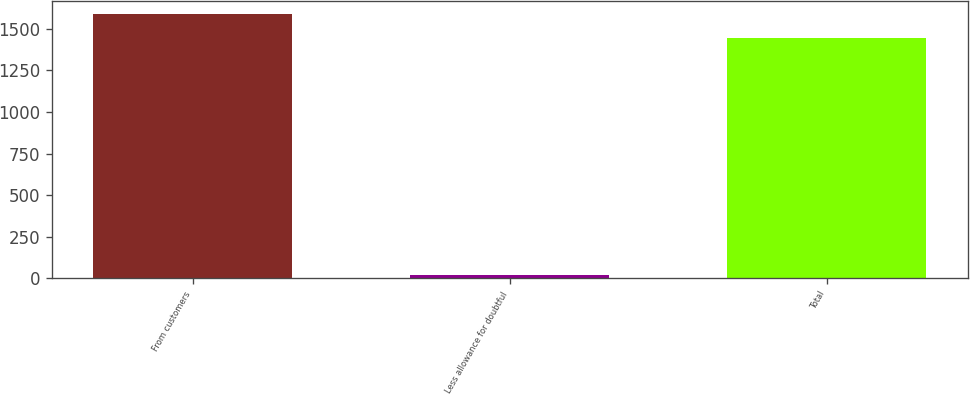Convert chart. <chart><loc_0><loc_0><loc_500><loc_500><bar_chart><fcel>From customers<fcel>Less allowance for doubtful<fcel>Total<nl><fcel>1591.04<fcel>19.9<fcel>1446.4<nl></chart> 